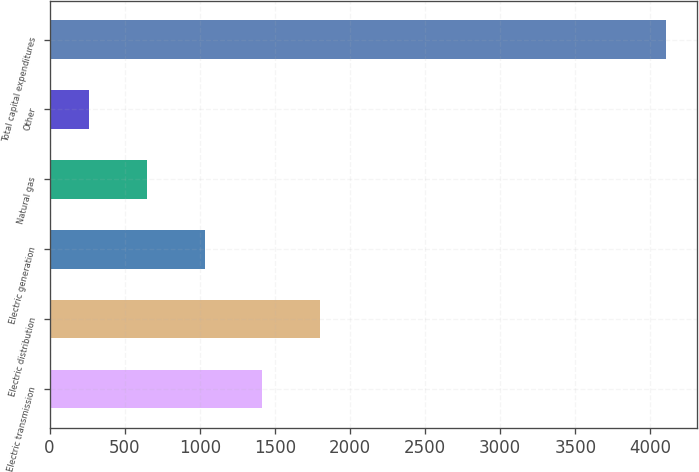<chart> <loc_0><loc_0><loc_500><loc_500><bar_chart><fcel>Electric transmission<fcel>Electric distribution<fcel>Electric generation<fcel>Natural gas<fcel>Other<fcel>Total capital expenditures<nl><fcel>1417<fcel>1801<fcel>1033<fcel>649<fcel>265<fcel>4105<nl></chart> 